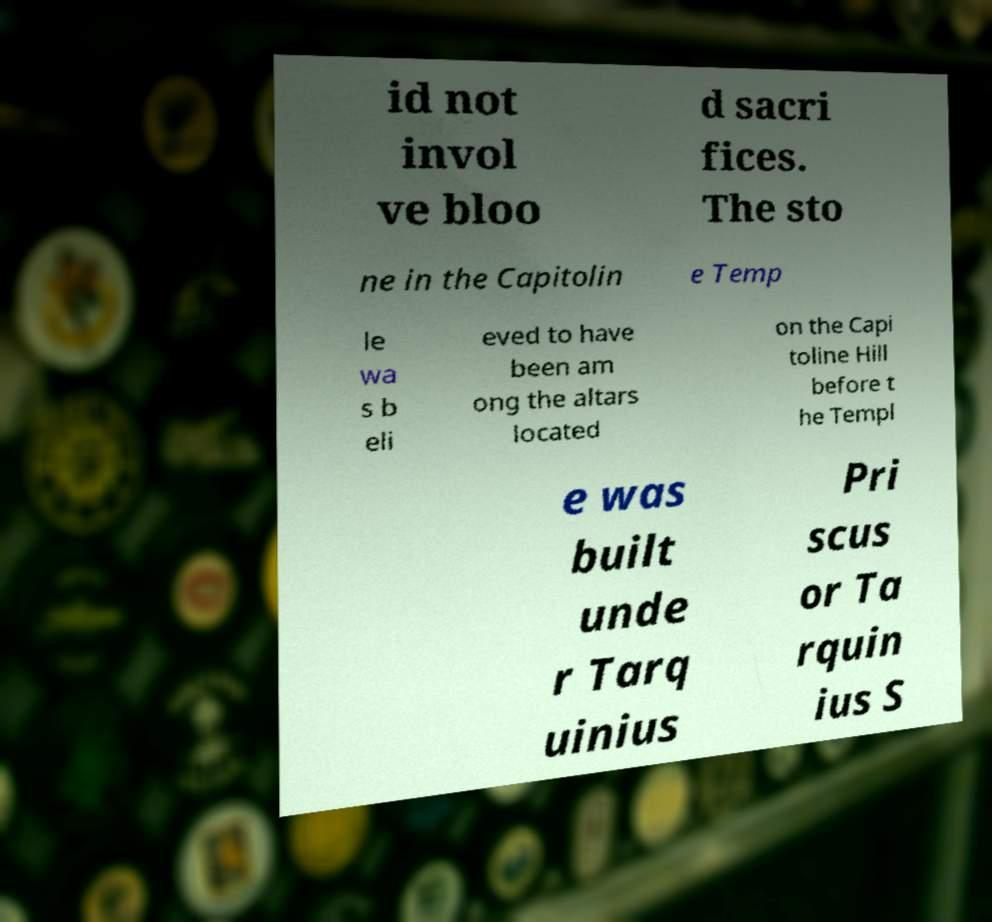For documentation purposes, I need the text within this image transcribed. Could you provide that? id not invol ve bloo d sacri fices. The sto ne in the Capitolin e Temp le wa s b eli eved to have been am ong the altars located on the Capi toline Hill before t he Templ e was built unde r Tarq uinius Pri scus or Ta rquin ius S 